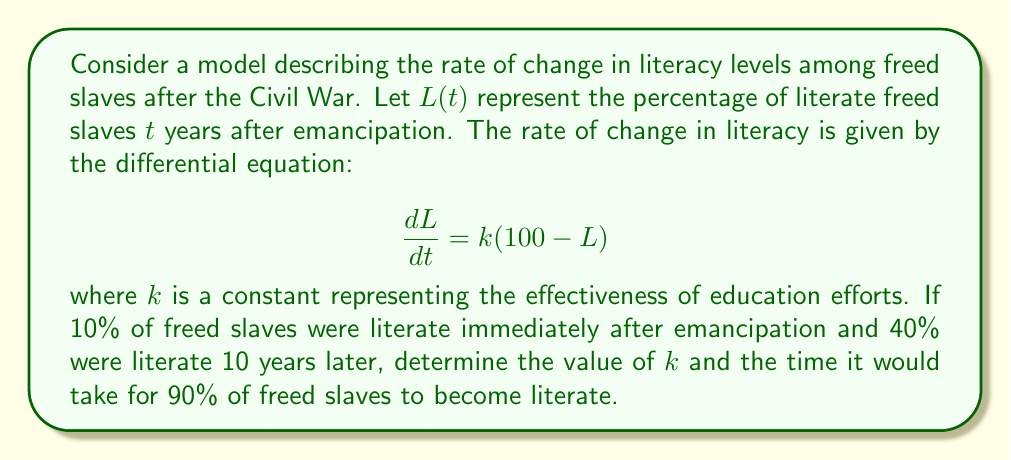What is the answer to this math problem? To solve this problem, we'll follow these steps:

1. Solve the differential equation
2. Use the initial condition to find the integration constant
3. Use the 10-year data point to find $k$
4. Use the solution to find the time for 90% literacy

Step 1: Solve the differential equation

The equation $\frac{dL}{dt} = k(100 - L)$ is separable. Rearranging:

$$\frac{dL}{100 - L} = k dt$$

Integrating both sides:

$$-\ln|100 - L| = kt + C$$

Solving for $L$:

$$L = 100 - Ae^{-kt}$$

where $A = e^C$.

Step 2: Use the initial condition

At $t = 0$, $L = 10$. Substituting:

$$10 = 100 - A$$
$$A = 90$$

So our solution is:

$$L = 100 - 90e^{-kt}$$

Step 3: Find $k$ using the 10-year data point

At $t = 10$, $L = 40$. Substituting:

$$40 = 100 - 90e^{-10k}$$
$$60 = 90e^{-10k}$$
$$\frac{2}{3} = e^{-10k}$$

Taking the natural log of both sides:

$$\ln(\frac{2}{3}) = -10k$$
$$k = -\frac{1}{10}\ln(\frac{2}{3}) \approx 0.0405$$

Step 4: Find the time for 90% literacy

Set $L = 90$ in our solution and solve for $t$:

$$90 = 100 - 90e^{-0.0405t}$$
$$10 = 90e^{-0.0405t}$$
$$\frac{1}{9} = e^{-0.0405t}$$

Taking the natural log of both sides:

$$\ln(\frac{1}{9}) = -0.0405t$$
$$t = -\frac{1}{0.0405}\ln(\frac{1}{9}) \approx 54.4$$
Answer: The value of $k$ is approximately 0.0405, and it would take approximately 54.4 years for 90% of freed slaves to become literate under this model. 